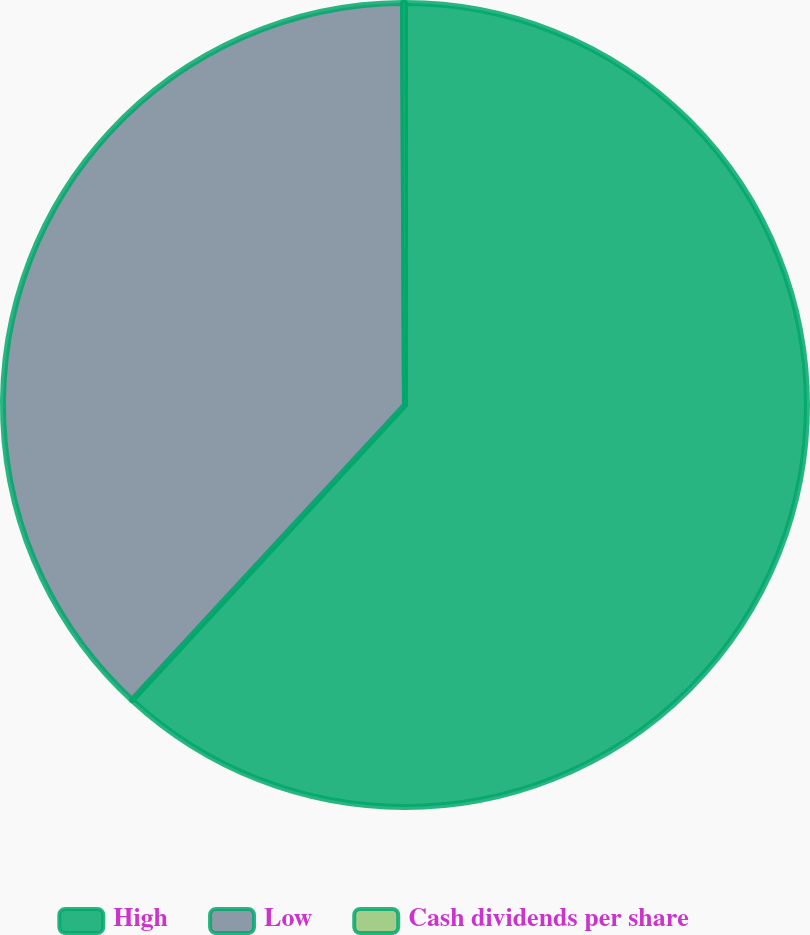Convert chart. <chart><loc_0><loc_0><loc_500><loc_500><pie_chart><fcel>High<fcel>Low<fcel>Cash dividends per share<nl><fcel>61.88%<fcel>38.04%<fcel>0.08%<nl></chart> 